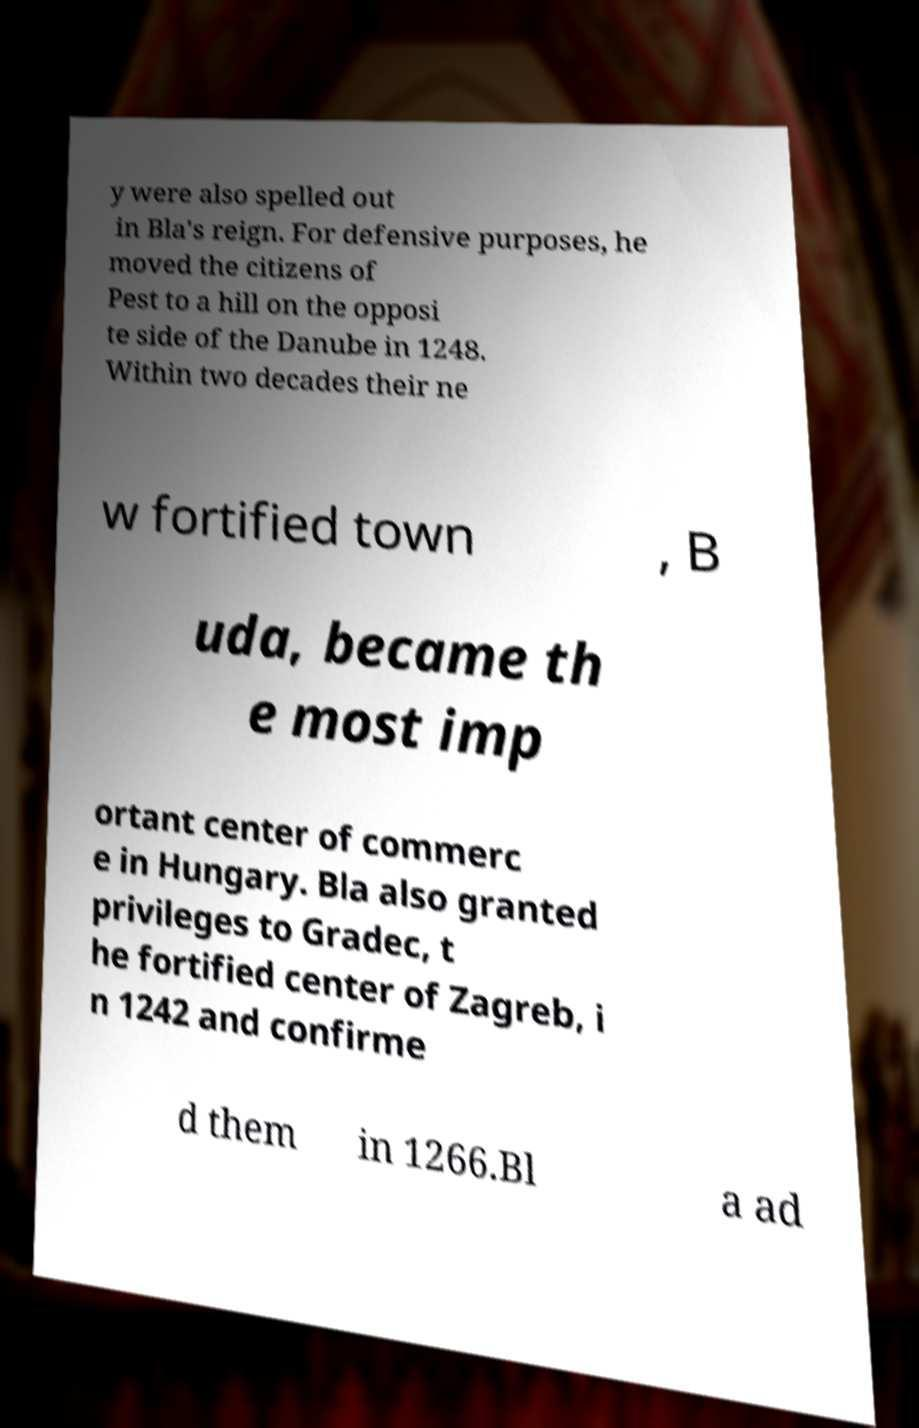Please identify and transcribe the text found in this image. y were also spelled out in Bla's reign. For defensive purposes, he moved the citizens of Pest to a hill on the opposi te side of the Danube in 1248. Within two decades their ne w fortified town , B uda, became th e most imp ortant center of commerc e in Hungary. Bla also granted privileges to Gradec, t he fortified center of Zagreb, i n 1242 and confirme d them in 1266.Bl a ad 